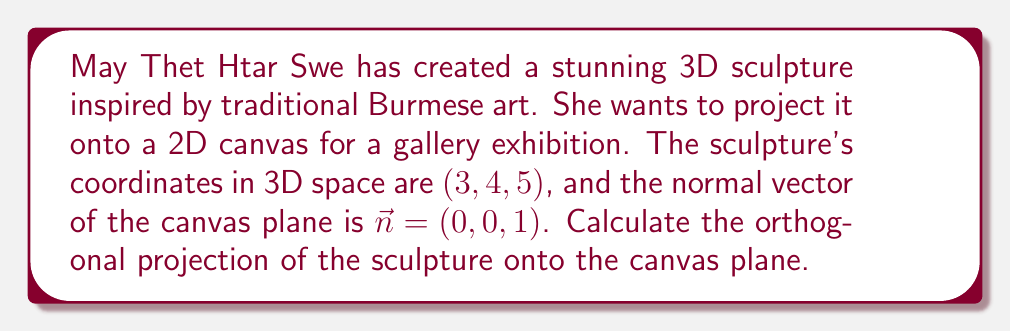Show me your answer to this math problem. To find the orthogonal projection of a 3D point onto a plane, we can follow these steps:

1. The plane equation is given by the normal vector $\vec{n} = (0, 0, 1)$. This means the plane is parallel to the xy-plane.

2. The point to be projected is $P = (3, 4, 5)$.

3. The formula for orthogonal projection of a point $P$ onto a plane with normal vector $\vec{n}$ is:

   $$P_{proj} = P - (\vec{P} \cdot \hat{n})\hat{n}$$

   where $\hat{n}$ is the unit normal vector.

4. The unit normal vector $\hat{n}$ is already $(0, 0, 1)$ since the given normal vector has a magnitude of 1.

5. Calculate the dot product $\vec{P} \cdot \hat{n}$:
   $$(3, 4, 5) \cdot (0, 0, 1) = 5$$

6. Multiply the result by $\hat{n}$:
   $$5(0, 0, 1) = (0, 0, 5)$$

7. Subtract this from the original point $P$:
   $$(3, 4, 5) - (0, 0, 5) = (3, 4, 0)$$

Therefore, the orthogonal projection of the sculpture onto the canvas plane is $(3, 4, 0)$.
Answer: $(3, 4, 0)$ 